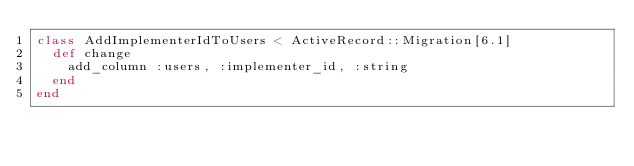Convert code to text. <code><loc_0><loc_0><loc_500><loc_500><_Ruby_>class AddImplementerIdToUsers < ActiveRecord::Migration[6.1]
  def change
    add_column :users, :implementer_id, :string
  end
end
</code> 